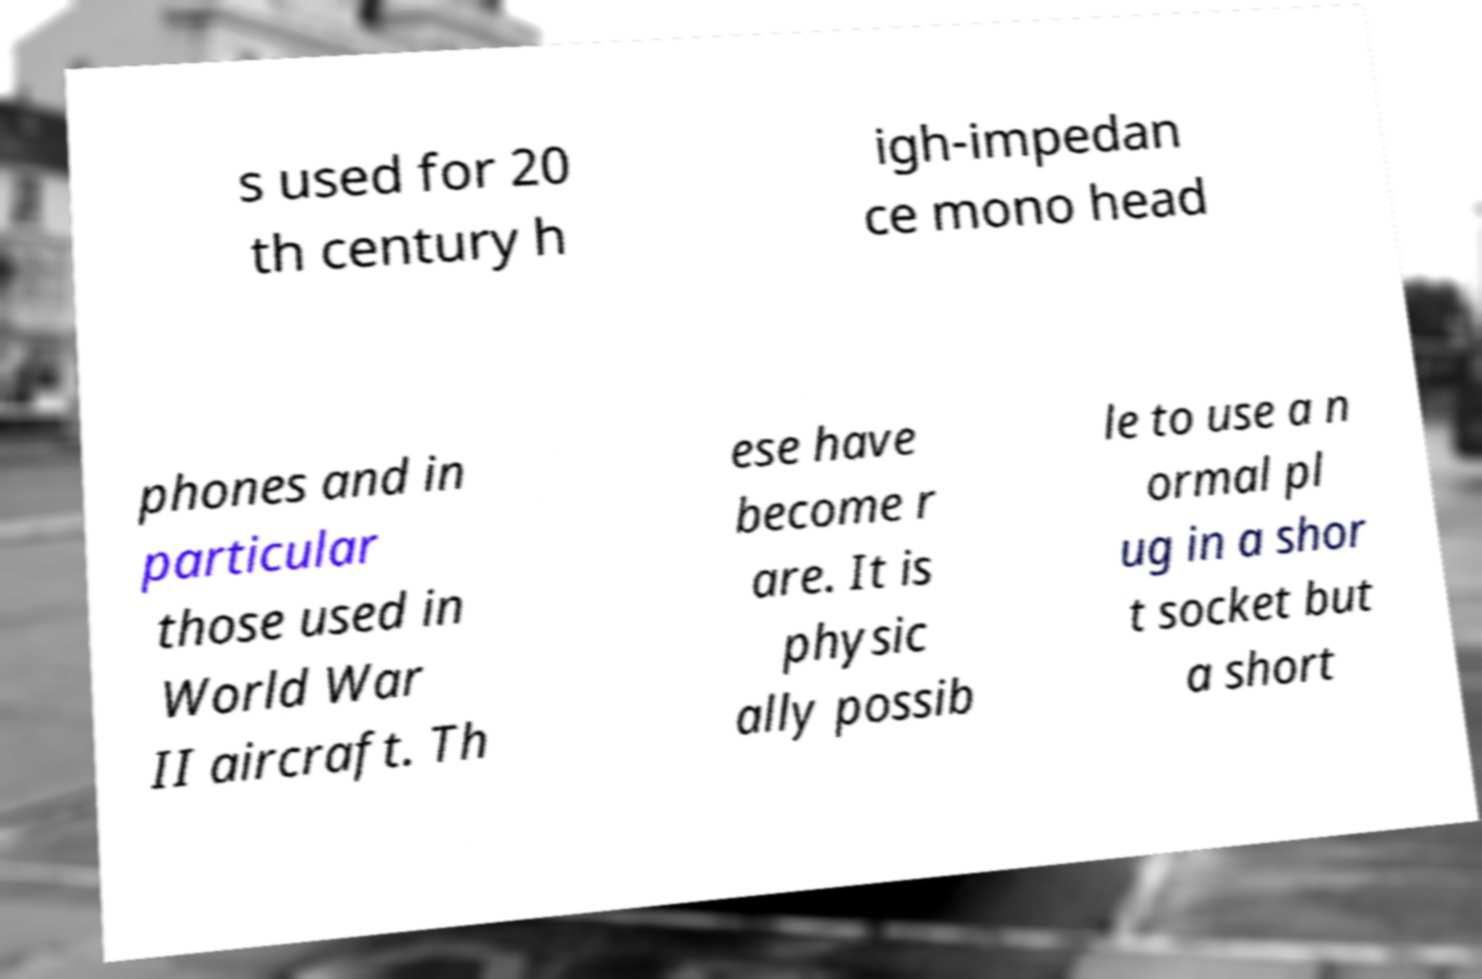Can you read and provide the text displayed in the image?This photo seems to have some interesting text. Can you extract and type it out for me? s used for 20 th century h igh-impedan ce mono head phones and in particular those used in World War II aircraft. Th ese have become r are. It is physic ally possib le to use a n ormal pl ug in a shor t socket but a short 